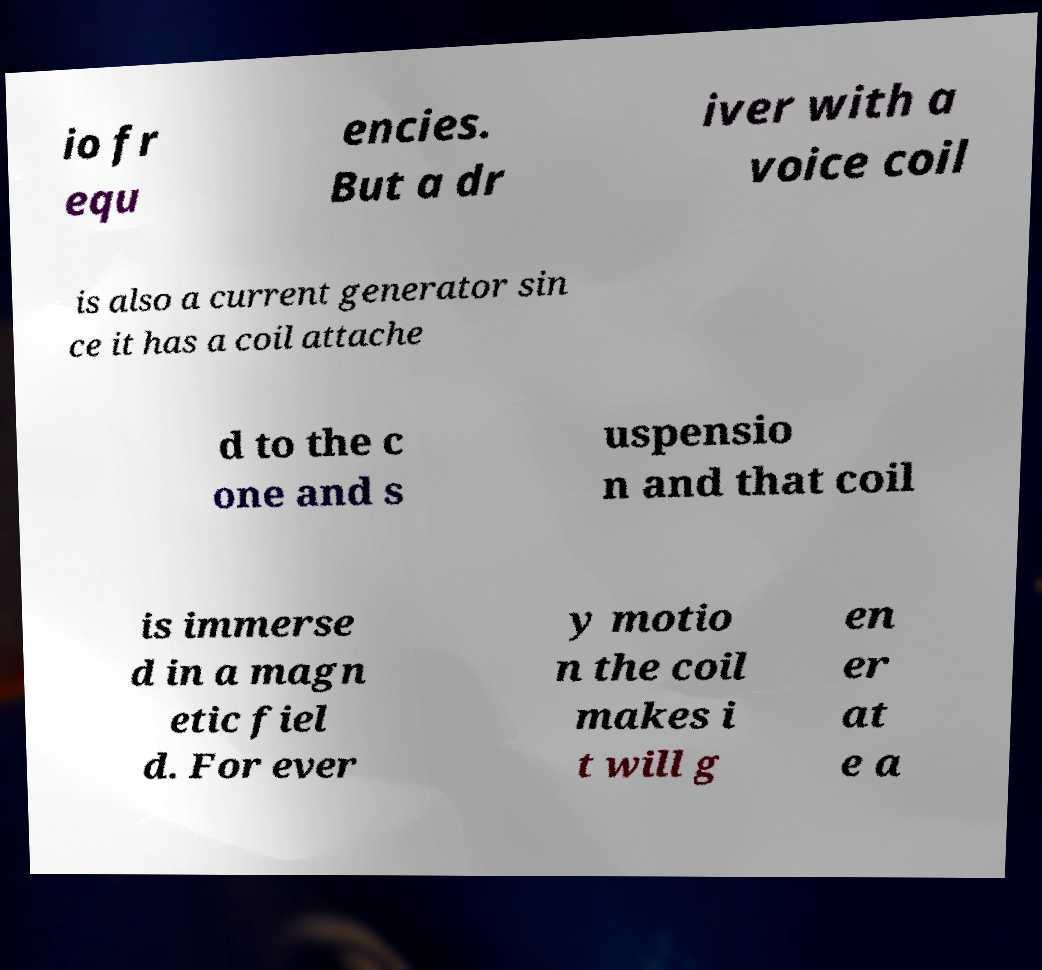Could you assist in decoding the text presented in this image and type it out clearly? io fr equ encies. But a dr iver with a voice coil is also a current generator sin ce it has a coil attache d to the c one and s uspensio n and that coil is immerse d in a magn etic fiel d. For ever y motio n the coil makes i t will g en er at e a 